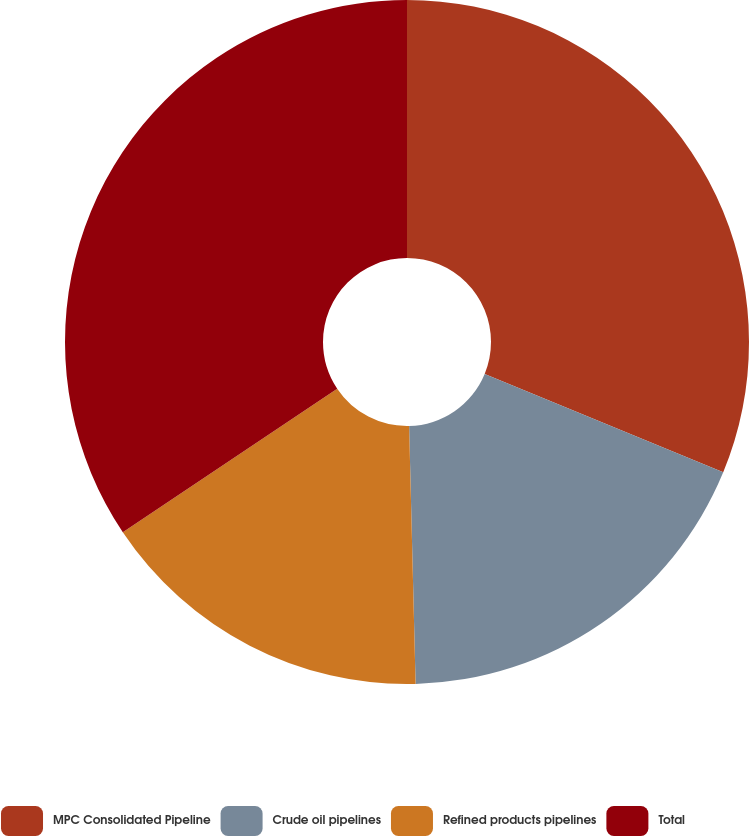Convert chart to OTSL. <chart><loc_0><loc_0><loc_500><loc_500><pie_chart><fcel>MPC Consolidated Pipeline<fcel>Crude oil pipelines<fcel>Refined products pipelines<fcel>Total<nl><fcel>31.22%<fcel>18.38%<fcel>16.01%<fcel>34.39%<nl></chart> 